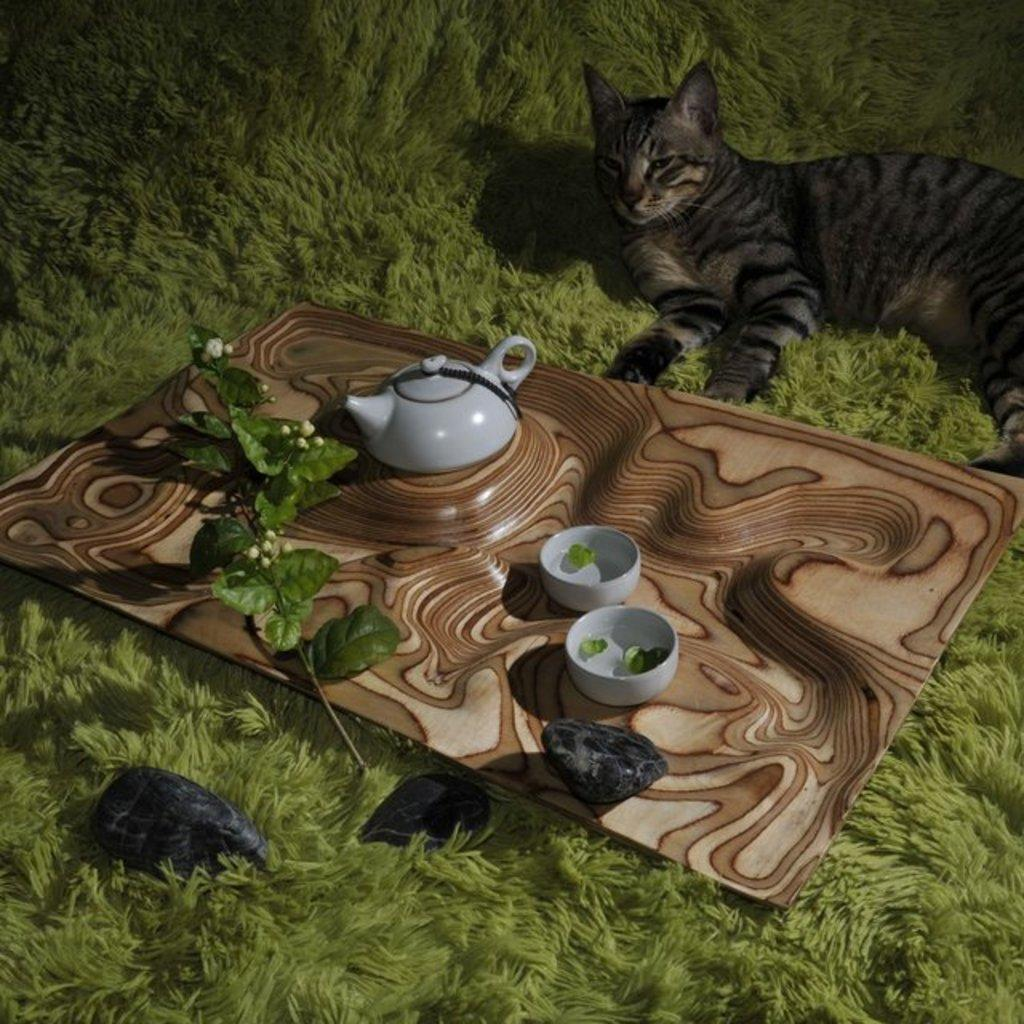What is located in the foreground of the image? There is a tray in the foreground of the image. What objects are on the tray? A kettle and bowls are present on the tray. Can you describe the background of the image? There is a cat lying on the grass in the background of the image. What time of day was the image taken? The image was taken during nighttime. What type of orange fruit can be seen in the image? There is no orange fruit present in the image. Is there a tiger visible in the background of the image? No, there is no tiger present in the image; it features a cat lying on the grass. How many pears are being used in the image? There are no pears present in the image. 